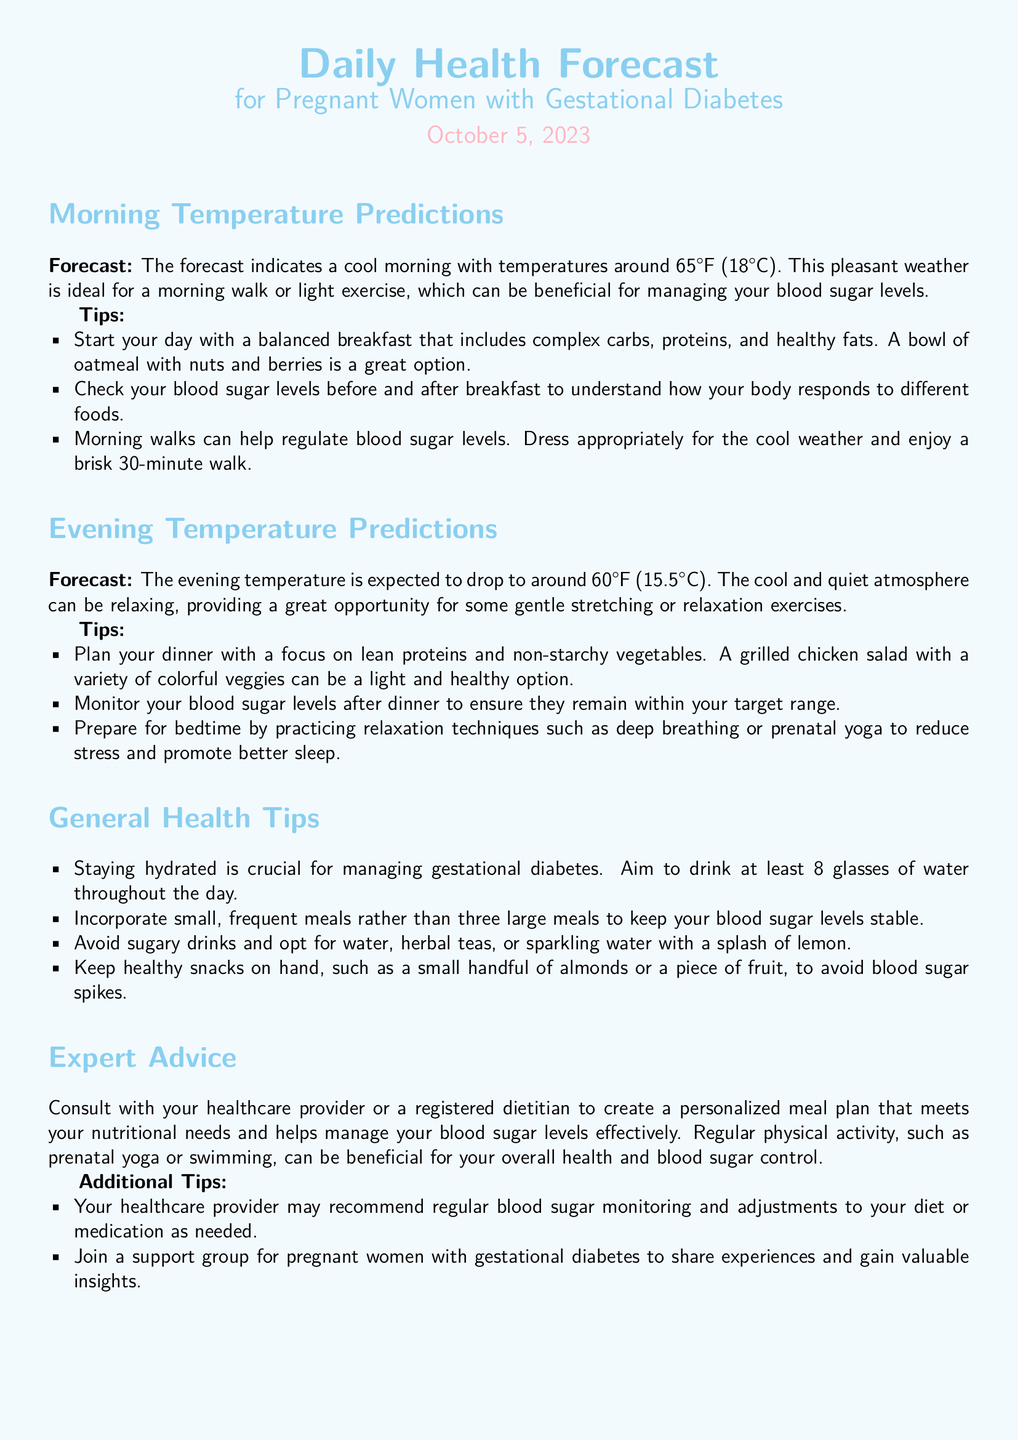what is the morning temperature prediction? The morning temperature prediction is stated as around 65°F (18°C).
Answer: 65°F (18°C) what is recommended for breakfast? The document suggests a balanced breakfast that includes complex carbs, proteins, and healthy fats, specifically mentioning oatmeal with nuts and berries.
Answer: oatmeal with nuts and berries what is the evening temperature prediction? The evening temperature prediction is expected to drop to around 60°F (15.5°C).
Answer: 60°F (15.5°C) what type of exercise is suggested for the morning? The forecast indicates that a morning walk or light exercise is beneficial for managing blood sugar levels.
Answer: morning walk what is a suggested dinner option? A grilled chicken salad with a variety of colorful veggies is recommended for dinner.
Answer: grilled chicken salad how many glasses of water should be aimed for daily? The document advises aiming to drink at least 8 glasses of water throughout the day.
Answer: 8 glasses what relaxation techniques are suggested before bedtime? The tips mention practicing relaxation techniques such as deep breathing or prenatal yoga.
Answer: deep breathing or prenatal yoga what is the general temperature change from morning to evening? The temperature drops from around 65°F in the morning to around 60°F in the evening.
Answer: 5°F drop who can help create a personalized meal plan? It is advised to consult with a healthcare provider or a registered dietitian for a personalized meal plan.
Answer: healthcare provider or registered dietitian 